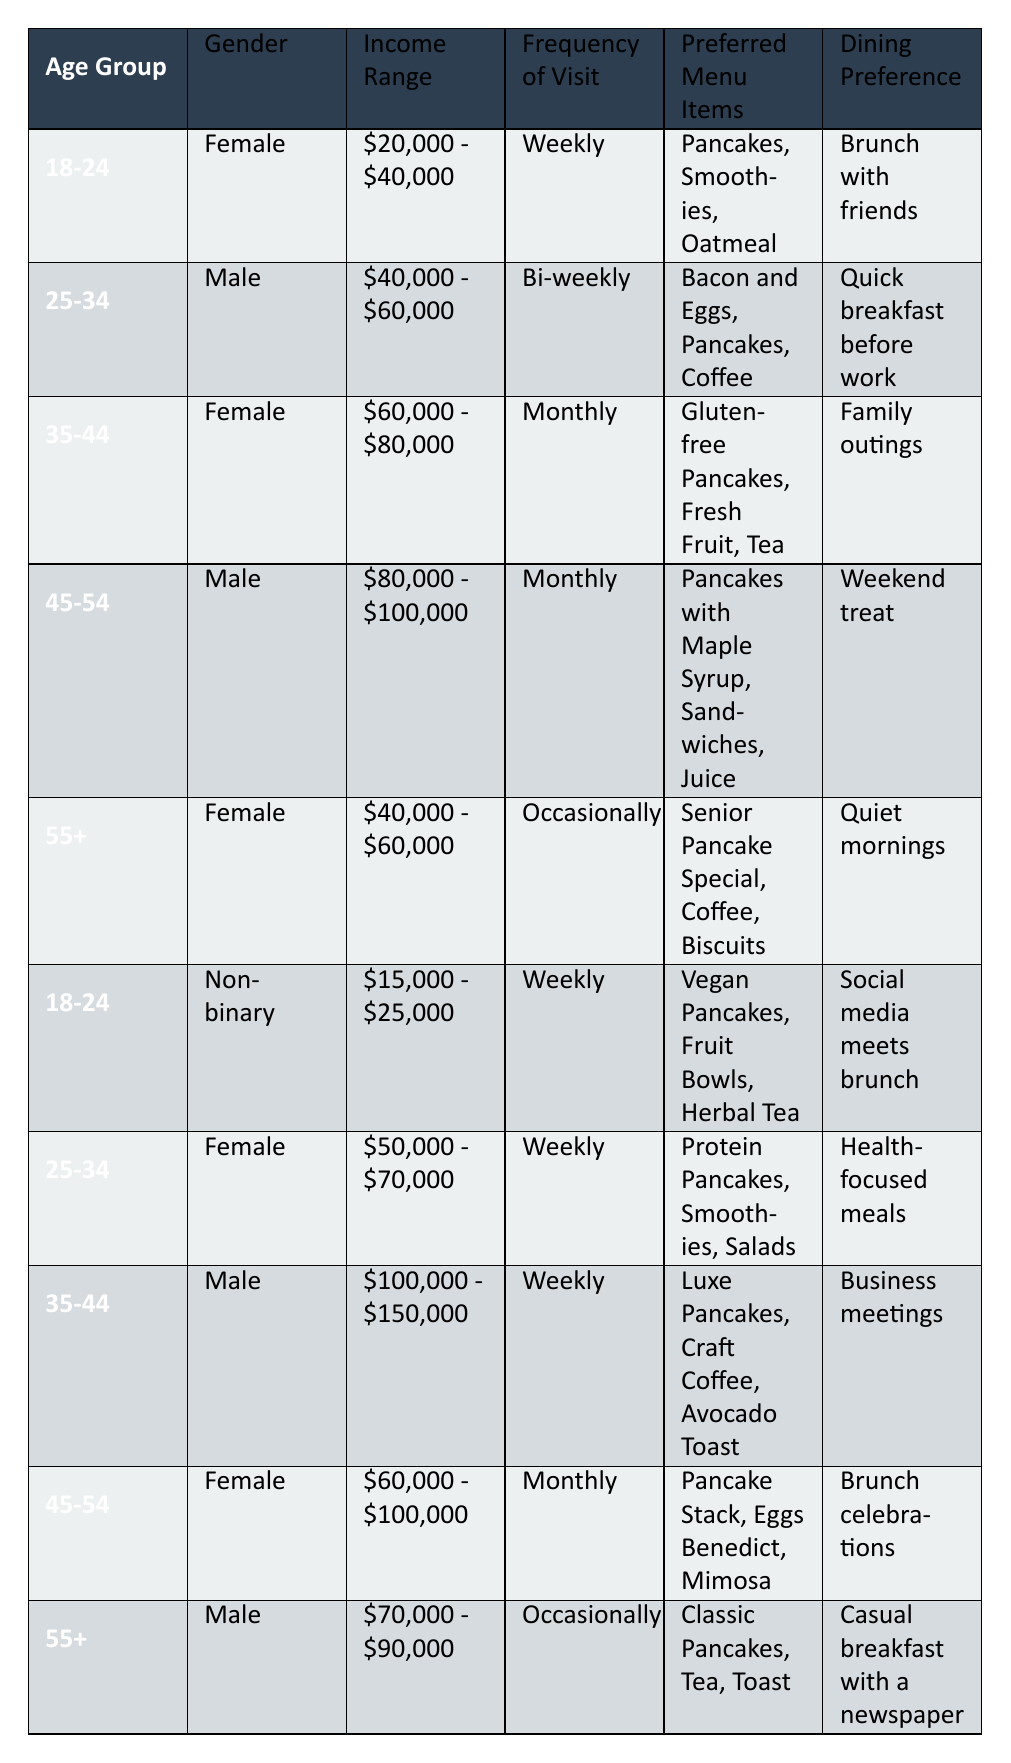What is the most preferred menu item for customers aged 18-24? The table shows two entries for the age group 18-24. The preferred menu items for the female customer are pancakes, smoothies, and oatmeal, while the non-binary customer prefers vegan pancakes, fruit bowls, and herbal tea. Both customers have pancakes listed as their preferred menu item, making it the most preferred item for this age group.
Answer: Pancakes Is there any customer in the income range of $80,000 - $100,000 who visits weekly? According to the table, the only customer in the income range of $80,000 - $100,000 is a male aged 45-54 who visits monthly. Therefore, there is no customer in this income range who visits weekly.
Answer: No How many customers prefer healthy menu items versus traditional breakfast items? Healthy menu items include vegan pancakes, protein pancakes, and salads (3 customers), while traditional items include pancakes, bacon and eggs, and classic pancakes (7 customers). There are significantly more customers preferring traditional items than healthy items.
Answer: Traditional: 7, Healthy: 3 Which location has customers that visit most frequently and what is their preferred menu item? The table shows that the locations with the highest frequency of visits (weekly) are Toronto and Halifax, each with one customer. The preferred menu item in Toronto (female) is pancakes, while in Halifax (female) it is protein pancakes.
Answer: Toronto: Pancakes, Halifax: Protein Pancakes What percentage of customers are female? There are 5 females out of 10 total customers in the table. To find the percentage, divide the number of female customers (5) by the total number of customers (10) and then multiply by 100. This results in (5/10) * 100 = 50%.
Answer: 50% Are there any non-binary customers who visit more than once a week? The table includes one non-binary customer aged 18-24 who visits weekly. There are no entries indicating any non-binary customers visiting more frequently than weekly.
Answer: No What is the average frequency of visits for the customers in the age group 35-44? In the age group 35-44, one female visits monthly and one male visits weekly. To find the average, we convert monthly (1) and weekly (4) into a numeric scale, yielding (1 + 4) / 2 = 2.5.
Answer: 2.5 Is there a male customer who prefers pancakes and how often does he visit? Yes, in the table, there are two male customers who prefer pancakes: one aged 25-34 visits bi-weekly and one aged 45-54 visits monthly.
Answer: Yes, bi-weekly and monthly What is the most popular dining preference among customers? The dining preferences are varied, with the most common being "Weekly" visits and "Social media meets brunch" being a unique preference. However, upon reviewing the data, it seems "Brunch" is a common theme among many customer preferences. The specific most popular preference is difficult to single out due to variations in responses.
Answer: Brunch 